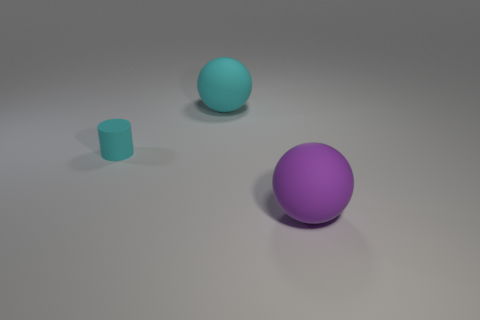What is the size of the matte thing that is the same color as the matte cylinder?
Make the answer very short. Large. Are there any other things that have the same shape as the small rubber thing?
Offer a very short reply. No. What shape is the object that is the same color as the rubber cylinder?
Provide a succinct answer. Sphere. Are there any large matte objects that are in front of the big thing in front of the big ball that is behind the cyan matte cylinder?
Your answer should be compact. No. There is a cyan object that is the same size as the purple object; what shape is it?
Ensure brevity in your answer.  Sphere. The other big thing that is the same shape as the large cyan rubber object is what color?
Provide a short and direct response. Purple. What number of objects are either purple matte balls or cylinders?
Make the answer very short. 2. There is a cyan matte object that is behind the tiny rubber thing; is its shape the same as the large matte object on the right side of the large cyan ball?
Give a very brief answer. Yes. What is the shape of the small cyan object that is left of the purple matte sphere?
Offer a terse response. Cylinder. Is the number of purple rubber objects that are behind the small cylinder the same as the number of large cyan things right of the cyan matte sphere?
Offer a very short reply. Yes. 